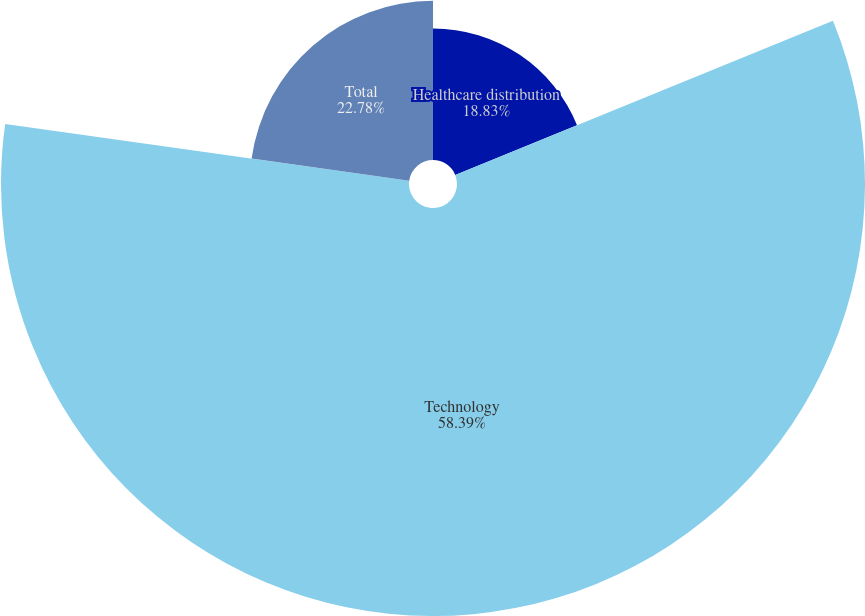Convert chart. <chart><loc_0><loc_0><loc_500><loc_500><pie_chart><fcel>Healthcare distribution<fcel>Technology<fcel>Total<nl><fcel>18.83%<fcel>58.39%<fcel>22.78%<nl></chart> 